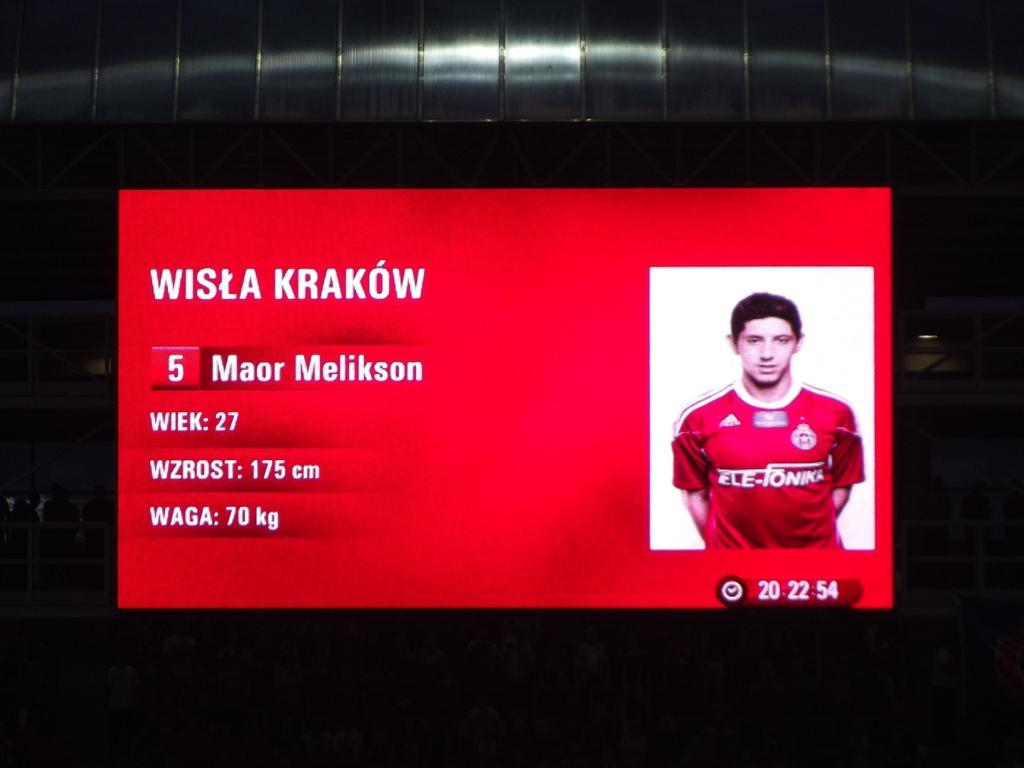<image>
Provide a brief description of the given image. Player number 5's photo and weight are shown on a red background. 